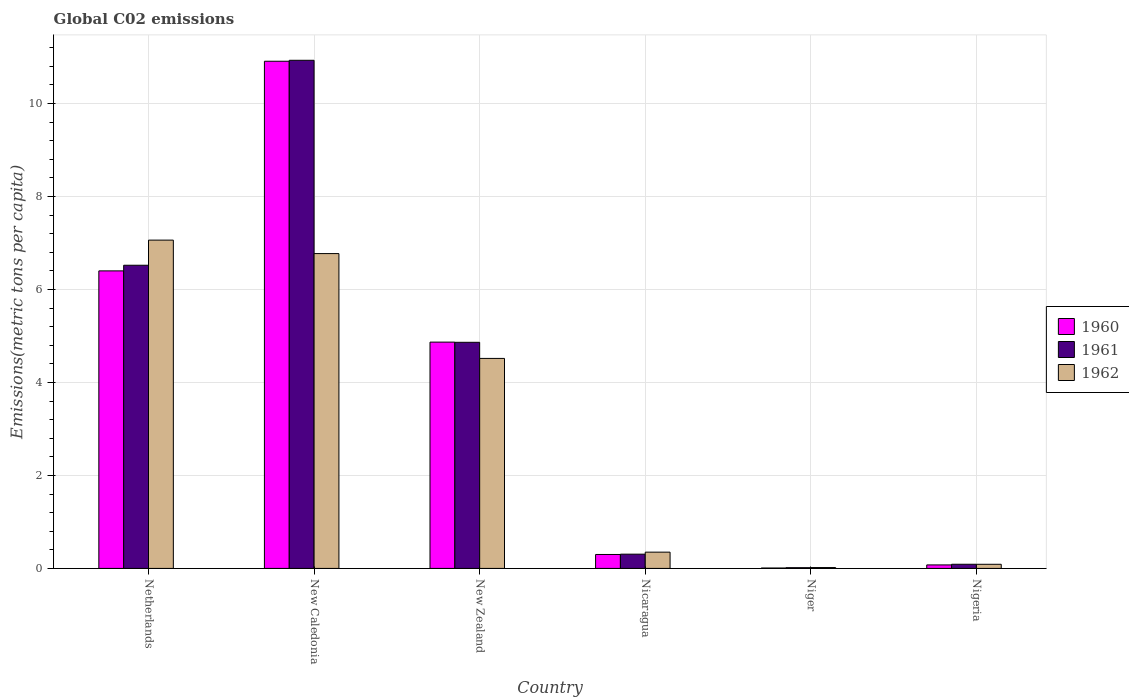How many different coloured bars are there?
Make the answer very short. 3. How many groups of bars are there?
Keep it short and to the point. 6. How many bars are there on the 4th tick from the left?
Make the answer very short. 3. What is the label of the 5th group of bars from the left?
Make the answer very short. Niger. In how many cases, is the number of bars for a given country not equal to the number of legend labels?
Your answer should be very brief. 0. What is the amount of CO2 emitted in in 1960 in New Zealand?
Provide a succinct answer. 4.87. Across all countries, what is the maximum amount of CO2 emitted in in 1962?
Your response must be concise. 7.06. Across all countries, what is the minimum amount of CO2 emitted in in 1961?
Your answer should be compact. 0.02. In which country was the amount of CO2 emitted in in 1961 maximum?
Your answer should be compact. New Caledonia. In which country was the amount of CO2 emitted in in 1962 minimum?
Give a very brief answer. Niger. What is the total amount of CO2 emitted in in 1961 in the graph?
Provide a succinct answer. 22.72. What is the difference between the amount of CO2 emitted in in 1962 in Netherlands and that in Nigeria?
Keep it short and to the point. 6.97. What is the difference between the amount of CO2 emitted in in 1960 in Nicaragua and the amount of CO2 emitted in in 1962 in New Zealand?
Provide a succinct answer. -4.22. What is the average amount of CO2 emitted in in 1960 per country?
Your response must be concise. 3.76. What is the difference between the amount of CO2 emitted in of/in 1962 and amount of CO2 emitted in of/in 1960 in New Caledonia?
Keep it short and to the point. -4.14. In how many countries, is the amount of CO2 emitted in in 1961 greater than 4 metric tons per capita?
Provide a short and direct response. 3. What is the ratio of the amount of CO2 emitted in in 1960 in Nicaragua to that in Niger?
Make the answer very short. 34.68. Is the amount of CO2 emitted in in 1960 in New Caledonia less than that in Nigeria?
Provide a succinct answer. No. What is the difference between the highest and the second highest amount of CO2 emitted in in 1960?
Provide a short and direct response. 6.04. What is the difference between the highest and the lowest amount of CO2 emitted in in 1960?
Offer a very short reply. 10.9. Is the sum of the amount of CO2 emitted in in 1962 in Netherlands and New Caledonia greater than the maximum amount of CO2 emitted in in 1960 across all countries?
Provide a succinct answer. Yes. What does the 3rd bar from the right in Netherlands represents?
Your response must be concise. 1960. How many countries are there in the graph?
Offer a terse response. 6. Are the values on the major ticks of Y-axis written in scientific E-notation?
Offer a very short reply. No. Where does the legend appear in the graph?
Keep it short and to the point. Center right. How many legend labels are there?
Give a very brief answer. 3. How are the legend labels stacked?
Provide a succinct answer. Vertical. What is the title of the graph?
Offer a terse response. Global C02 emissions. Does "1994" appear as one of the legend labels in the graph?
Your answer should be compact. No. What is the label or title of the Y-axis?
Your response must be concise. Emissions(metric tons per capita). What is the Emissions(metric tons per capita) of 1960 in Netherlands?
Keep it short and to the point. 6.4. What is the Emissions(metric tons per capita) in 1961 in Netherlands?
Keep it short and to the point. 6.52. What is the Emissions(metric tons per capita) of 1962 in Netherlands?
Provide a short and direct response. 7.06. What is the Emissions(metric tons per capita) of 1960 in New Caledonia?
Offer a very short reply. 10.91. What is the Emissions(metric tons per capita) of 1961 in New Caledonia?
Make the answer very short. 10.93. What is the Emissions(metric tons per capita) of 1962 in New Caledonia?
Give a very brief answer. 6.77. What is the Emissions(metric tons per capita) in 1960 in New Zealand?
Provide a short and direct response. 4.87. What is the Emissions(metric tons per capita) of 1961 in New Zealand?
Give a very brief answer. 4.86. What is the Emissions(metric tons per capita) in 1962 in New Zealand?
Ensure brevity in your answer.  4.52. What is the Emissions(metric tons per capita) in 1960 in Nicaragua?
Provide a short and direct response. 0.3. What is the Emissions(metric tons per capita) in 1961 in Nicaragua?
Your answer should be compact. 0.31. What is the Emissions(metric tons per capita) of 1962 in Nicaragua?
Your response must be concise. 0.35. What is the Emissions(metric tons per capita) of 1960 in Niger?
Your answer should be compact. 0.01. What is the Emissions(metric tons per capita) in 1961 in Niger?
Give a very brief answer. 0.02. What is the Emissions(metric tons per capita) of 1962 in Niger?
Provide a short and direct response. 0.02. What is the Emissions(metric tons per capita) in 1960 in Nigeria?
Your response must be concise. 0.08. What is the Emissions(metric tons per capita) in 1961 in Nigeria?
Ensure brevity in your answer.  0.09. What is the Emissions(metric tons per capita) of 1962 in Nigeria?
Offer a very short reply. 0.09. Across all countries, what is the maximum Emissions(metric tons per capita) in 1960?
Your answer should be compact. 10.91. Across all countries, what is the maximum Emissions(metric tons per capita) of 1961?
Make the answer very short. 10.93. Across all countries, what is the maximum Emissions(metric tons per capita) of 1962?
Provide a short and direct response. 7.06. Across all countries, what is the minimum Emissions(metric tons per capita) in 1960?
Offer a very short reply. 0.01. Across all countries, what is the minimum Emissions(metric tons per capita) of 1961?
Provide a succinct answer. 0.02. Across all countries, what is the minimum Emissions(metric tons per capita) in 1962?
Your response must be concise. 0.02. What is the total Emissions(metric tons per capita) in 1960 in the graph?
Make the answer very short. 22.56. What is the total Emissions(metric tons per capita) of 1961 in the graph?
Ensure brevity in your answer.  22.72. What is the total Emissions(metric tons per capita) in 1962 in the graph?
Your answer should be compact. 18.81. What is the difference between the Emissions(metric tons per capita) of 1960 in Netherlands and that in New Caledonia?
Your answer should be very brief. -4.51. What is the difference between the Emissions(metric tons per capita) in 1961 in Netherlands and that in New Caledonia?
Provide a short and direct response. -4.41. What is the difference between the Emissions(metric tons per capita) in 1962 in Netherlands and that in New Caledonia?
Make the answer very short. 0.29. What is the difference between the Emissions(metric tons per capita) in 1960 in Netherlands and that in New Zealand?
Offer a very short reply. 1.53. What is the difference between the Emissions(metric tons per capita) in 1961 in Netherlands and that in New Zealand?
Provide a short and direct response. 1.66. What is the difference between the Emissions(metric tons per capita) of 1962 in Netherlands and that in New Zealand?
Provide a succinct answer. 2.54. What is the difference between the Emissions(metric tons per capita) in 1960 in Netherlands and that in Nicaragua?
Make the answer very short. 6.1. What is the difference between the Emissions(metric tons per capita) of 1961 in Netherlands and that in Nicaragua?
Make the answer very short. 6.21. What is the difference between the Emissions(metric tons per capita) of 1962 in Netherlands and that in Nicaragua?
Provide a short and direct response. 6.71. What is the difference between the Emissions(metric tons per capita) of 1960 in Netherlands and that in Niger?
Your response must be concise. 6.39. What is the difference between the Emissions(metric tons per capita) of 1961 in Netherlands and that in Niger?
Provide a succinct answer. 6.5. What is the difference between the Emissions(metric tons per capita) in 1962 in Netherlands and that in Niger?
Give a very brief answer. 7.04. What is the difference between the Emissions(metric tons per capita) of 1960 in Netherlands and that in Nigeria?
Your answer should be compact. 6.32. What is the difference between the Emissions(metric tons per capita) of 1961 in Netherlands and that in Nigeria?
Give a very brief answer. 6.43. What is the difference between the Emissions(metric tons per capita) in 1962 in Netherlands and that in Nigeria?
Your response must be concise. 6.97. What is the difference between the Emissions(metric tons per capita) in 1960 in New Caledonia and that in New Zealand?
Keep it short and to the point. 6.04. What is the difference between the Emissions(metric tons per capita) in 1961 in New Caledonia and that in New Zealand?
Your response must be concise. 6.07. What is the difference between the Emissions(metric tons per capita) in 1962 in New Caledonia and that in New Zealand?
Provide a succinct answer. 2.25. What is the difference between the Emissions(metric tons per capita) of 1960 in New Caledonia and that in Nicaragua?
Your response must be concise. 10.61. What is the difference between the Emissions(metric tons per capita) in 1961 in New Caledonia and that in Nicaragua?
Provide a short and direct response. 10.62. What is the difference between the Emissions(metric tons per capita) of 1962 in New Caledonia and that in Nicaragua?
Your answer should be very brief. 6.42. What is the difference between the Emissions(metric tons per capita) of 1960 in New Caledonia and that in Niger?
Give a very brief answer. 10.9. What is the difference between the Emissions(metric tons per capita) in 1961 in New Caledonia and that in Niger?
Provide a succinct answer. 10.91. What is the difference between the Emissions(metric tons per capita) of 1962 in New Caledonia and that in Niger?
Provide a short and direct response. 6.75. What is the difference between the Emissions(metric tons per capita) of 1960 in New Caledonia and that in Nigeria?
Your answer should be very brief. 10.83. What is the difference between the Emissions(metric tons per capita) of 1961 in New Caledonia and that in Nigeria?
Provide a succinct answer. 10.84. What is the difference between the Emissions(metric tons per capita) of 1962 in New Caledonia and that in Nigeria?
Your response must be concise. 6.68. What is the difference between the Emissions(metric tons per capita) of 1960 in New Zealand and that in Nicaragua?
Ensure brevity in your answer.  4.57. What is the difference between the Emissions(metric tons per capita) in 1961 in New Zealand and that in Nicaragua?
Ensure brevity in your answer.  4.56. What is the difference between the Emissions(metric tons per capita) of 1962 in New Zealand and that in Nicaragua?
Offer a terse response. 4.17. What is the difference between the Emissions(metric tons per capita) in 1960 in New Zealand and that in Niger?
Provide a succinct answer. 4.86. What is the difference between the Emissions(metric tons per capita) of 1961 in New Zealand and that in Niger?
Offer a very short reply. 4.85. What is the difference between the Emissions(metric tons per capita) of 1962 in New Zealand and that in Niger?
Offer a very short reply. 4.5. What is the difference between the Emissions(metric tons per capita) of 1960 in New Zealand and that in Nigeria?
Ensure brevity in your answer.  4.79. What is the difference between the Emissions(metric tons per capita) in 1961 in New Zealand and that in Nigeria?
Your response must be concise. 4.77. What is the difference between the Emissions(metric tons per capita) in 1962 in New Zealand and that in Nigeria?
Offer a terse response. 4.43. What is the difference between the Emissions(metric tons per capita) in 1960 in Nicaragua and that in Niger?
Make the answer very short. 0.29. What is the difference between the Emissions(metric tons per capita) of 1961 in Nicaragua and that in Niger?
Provide a succinct answer. 0.29. What is the difference between the Emissions(metric tons per capita) in 1962 in Nicaragua and that in Niger?
Your answer should be compact. 0.33. What is the difference between the Emissions(metric tons per capita) in 1960 in Nicaragua and that in Nigeria?
Offer a very short reply. 0.22. What is the difference between the Emissions(metric tons per capita) in 1961 in Nicaragua and that in Nigeria?
Your response must be concise. 0.22. What is the difference between the Emissions(metric tons per capita) of 1962 in Nicaragua and that in Nigeria?
Provide a short and direct response. 0.26. What is the difference between the Emissions(metric tons per capita) of 1960 in Niger and that in Nigeria?
Provide a succinct answer. -0.07. What is the difference between the Emissions(metric tons per capita) of 1961 in Niger and that in Nigeria?
Provide a short and direct response. -0.07. What is the difference between the Emissions(metric tons per capita) of 1962 in Niger and that in Nigeria?
Your answer should be very brief. -0.07. What is the difference between the Emissions(metric tons per capita) of 1960 in Netherlands and the Emissions(metric tons per capita) of 1961 in New Caledonia?
Provide a short and direct response. -4.53. What is the difference between the Emissions(metric tons per capita) of 1960 in Netherlands and the Emissions(metric tons per capita) of 1962 in New Caledonia?
Keep it short and to the point. -0.37. What is the difference between the Emissions(metric tons per capita) of 1961 in Netherlands and the Emissions(metric tons per capita) of 1962 in New Caledonia?
Your answer should be compact. -0.25. What is the difference between the Emissions(metric tons per capita) in 1960 in Netherlands and the Emissions(metric tons per capita) in 1961 in New Zealand?
Offer a very short reply. 1.54. What is the difference between the Emissions(metric tons per capita) in 1960 in Netherlands and the Emissions(metric tons per capita) in 1962 in New Zealand?
Provide a short and direct response. 1.88. What is the difference between the Emissions(metric tons per capita) in 1961 in Netherlands and the Emissions(metric tons per capita) in 1962 in New Zealand?
Keep it short and to the point. 2. What is the difference between the Emissions(metric tons per capita) of 1960 in Netherlands and the Emissions(metric tons per capita) of 1961 in Nicaragua?
Your answer should be compact. 6.09. What is the difference between the Emissions(metric tons per capita) in 1960 in Netherlands and the Emissions(metric tons per capita) in 1962 in Nicaragua?
Offer a very short reply. 6.05. What is the difference between the Emissions(metric tons per capita) of 1961 in Netherlands and the Emissions(metric tons per capita) of 1962 in Nicaragua?
Offer a terse response. 6.17. What is the difference between the Emissions(metric tons per capita) in 1960 in Netherlands and the Emissions(metric tons per capita) in 1961 in Niger?
Your response must be concise. 6.38. What is the difference between the Emissions(metric tons per capita) of 1960 in Netherlands and the Emissions(metric tons per capita) of 1962 in Niger?
Provide a succinct answer. 6.38. What is the difference between the Emissions(metric tons per capita) of 1961 in Netherlands and the Emissions(metric tons per capita) of 1962 in Niger?
Make the answer very short. 6.5. What is the difference between the Emissions(metric tons per capita) of 1960 in Netherlands and the Emissions(metric tons per capita) of 1961 in Nigeria?
Your answer should be compact. 6.31. What is the difference between the Emissions(metric tons per capita) of 1960 in Netherlands and the Emissions(metric tons per capita) of 1962 in Nigeria?
Your answer should be very brief. 6.31. What is the difference between the Emissions(metric tons per capita) in 1961 in Netherlands and the Emissions(metric tons per capita) in 1962 in Nigeria?
Give a very brief answer. 6.43. What is the difference between the Emissions(metric tons per capita) in 1960 in New Caledonia and the Emissions(metric tons per capita) in 1961 in New Zealand?
Make the answer very short. 6.04. What is the difference between the Emissions(metric tons per capita) of 1960 in New Caledonia and the Emissions(metric tons per capita) of 1962 in New Zealand?
Your answer should be compact. 6.39. What is the difference between the Emissions(metric tons per capita) in 1961 in New Caledonia and the Emissions(metric tons per capita) in 1962 in New Zealand?
Offer a very short reply. 6.41. What is the difference between the Emissions(metric tons per capita) of 1960 in New Caledonia and the Emissions(metric tons per capita) of 1961 in Nicaragua?
Your answer should be compact. 10.6. What is the difference between the Emissions(metric tons per capita) of 1960 in New Caledonia and the Emissions(metric tons per capita) of 1962 in Nicaragua?
Provide a short and direct response. 10.56. What is the difference between the Emissions(metric tons per capita) of 1961 in New Caledonia and the Emissions(metric tons per capita) of 1962 in Nicaragua?
Provide a succinct answer. 10.58. What is the difference between the Emissions(metric tons per capita) in 1960 in New Caledonia and the Emissions(metric tons per capita) in 1961 in Niger?
Offer a very short reply. 10.89. What is the difference between the Emissions(metric tons per capita) of 1960 in New Caledonia and the Emissions(metric tons per capita) of 1962 in Niger?
Ensure brevity in your answer.  10.89. What is the difference between the Emissions(metric tons per capita) in 1961 in New Caledonia and the Emissions(metric tons per capita) in 1962 in Niger?
Provide a short and direct response. 10.91. What is the difference between the Emissions(metric tons per capita) of 1960 in New Caledonia and the Emissions(metric tons per capita) of 1961 in Nigeria?
Your answer should be very brief. 10.82. What is the difference between the Emissions(metric tons per capita) of 1960 in New Caledonia and the Emissions(metric tons per capita) of 1962 in Nigeria?
Your answer should be compact. 10.82. What is the difference between the Emissions(metric tons per capita) of 1961 in New Caledonia and the Emissions(metric tons per capita) of 1962 in Nigeria?
Provide a short and direct response. 10.84. What is the difference between the Emissions(metric tons per capita) in 1960 in New Zealand and the Emissions(metric tons per capita) in 1961 in Nicaragua?
Offer a terse response. 4.56. What is the difference between the Emissions(metric tons per capita) of 1960 in New Zealand and the Emissions(metric tons per capita) of 1962 in Nicaragua?
Provide a succinct answer. 4.52. What is the difference between the Emissions(metric tons per capita) in 1961 in New Zealand and the Emissions(metric tons per capita) in 1962 in Nicaragua?
Keep it short and to the point. 4.51. What is the difference between the Emissions(metric tons per capita) of 1960 in New Zealand and the Emissions(metric tons per capita) of 1961 in Niger?
Your answer should be compact. 4.85. What is the difference between the Emissions(metric tons per capita) of 1960 in New Zealand and the Emissions(metric tons per capita) of 1962 in Niger?
Give a very brief answer. 4.85. What is the difference between the Emissions(metric tons per capita) in 1961 in New Zealand and the Emissions(metric tons per capita) in 1962 in Niger?
Your answer should be compact. 4.84. What is the difference between the Emissions(metric tons per capita) in 1960 in New Zealand and the Emissions(metric tons per capita) in 1961 in Nigeria?
Keep it short and to the point. 4.78. What is the difference between the Emissions(metric tons per capita) of 1960 in New Zealand and the Emissions(metric tons per capita) of 1962 in Nigeria?
Give a very brief answer. 4.78. What is the difference between the Emissions(metric tons per capita) in 1961 in New Zealand and the Emissions(metric tons per capita) in 1962 in Nigeria?
Give a very brief answer. 4.77. What is the difference between the Emissions(metric tons per capita) in 1960 in Nicaragua and the Emissions(metric tons per capita) in 1961 in Niger?
Keep it short and to the point. 0.28. What is the difference between the Emissions(metric tons per capita) of 1960 in Nicaragua and the Emissions(metric tons per capita) of 1962 in Niger?
Give a very brief answer. 0.28. What is the difference between the Emissions(metric tons per capita) of 1961 in Nicaragua and the Emissions(metric tons per capita) of 1962 in Niger?
Your answer should be compact. 0.29. What is the difference between the Emissions(metric tons per capita) in 1960 in Nicaragua and the Emissions(metric tons per capita) in 1961 in Nigeria?
Make the answer very short. 0.21. What is the difference between the Emissions(metric tons per capita) in 1960 in Nicaragua and the Emissions(metric tons per capita) in 1962 in Nigeria?
Your answer should be very brief. 0.21. What is the difference between the Emissions(metric tons per capita) in 1961 in Nicaragua and the Emissions(metric tons per capita) in 1962 in Nigeria?
Offer a terse response. 0.22. What is the difference between the Emissions(metric tons per capita) of 1960 in Niger and the Emissions(metric tons per capita) of 1961 in Nigeria?
Make the answer very short. -0.08. What is the difference between the Emissions(metric tons per capita) in 1960 in Niger and the Emissions(metric tons per capita) in 1962 in Nigeria?
Ensure brevity in your answer.  -0.08. What is the difference between the Emissions(metric tons per capita) of 1961 in Niger and the Emissions(metric tons per capita) of 1962 in Nigeria?
Your response must be concise. -0.07. What is the average Emissions(metric tons per capita) of 1960 per country?
Your answer should be compact. 3.76. What is the average Emissions(metric tons per capita) of 1961 per country?
Provide a succinct answer. 3.79. What is the average Emissions(metric tons per capita) of 1962 per country?
Ensure brevity in your answer.  3.13. What is the difference between the Emissions(metric tons per capita) in 1960 and Emissions(metric tons per capita) in 1961 in Netherlands?
Your answer should be compact. -0.12. What is the difference between the Emissions(metric tons per capita) in 1960 and Emissions(metric tons per capita) in 1962 in Netherlands?
Your answer should be very brief. -0.66. What is the difference between the Emissions(metric tons per capita) in 1961 and Emissions(metric tons per capita) in 1962 in Netherlands?
Offer a very short reply. -0.54. What is the difference between the Emissions(metric tons per capita) in 1960 and Emissions(metric tons per capita) in 1961 in New Caledonia?
Your answer should be compact. -0.02. What is the difference between the Emissions(metric tons per capita) of 1960 and Emissions(metric tons per capita) of 1962 in New Caledonia?
Your answer should be very brief. 4.14. What is the difference between the Emissions(metric tons per capita) in 1961 and Emissions(metric tons per capita) in 1962 in New Caledonia?
Your answer should be compact. 4.16. What is the difference between the Emissions(metric tons per capita) of 1960 and Emissions(metric tons per capita) of 1961 in New Zealand?
Provide a succinct answer. 0. What is the difference between the Emissions(metric tons per capita) in 1960 and Emissions(metric tons per capita) in 1962 in New Zealand?
Ensure brevity in your answer.  0.35. What is the difference between the Emissions(metric tons per capita) of 1961 and Emissions(metric tons per capita) of 1962 in New Zealand?
Your answer should be very brief. 0.35. What is the difference between the Emissions(metric tons per capita) in 1960 and Emissions(metric tons per capita) in 1961 in Nicaragua?
Provide a short and direct response. -0.01. What is the difference between the Emissions(metric tons per capita) in 1960 and Emissions(metric tons per capita) in 1962 in Nicaragua?
Give a very brief answer. -0.05. What is the difference between the Emissions(metric tons per capita) in 1961 and Emissions(metric tons per capita) in 1962 in Nicaragua?
Give a very brief answer. -0.04. What is the difference between the Emissions(metric tons per capita) in 1960 and Emissions(metric tons per capita) in 1961 in Niger?
Your response must be concise. -0.01. What is the difference between the Emissions(metric tons per capita) in 1960 and Emissions(metric tons per capita) in 1962 in Niger?
Your answer should be compact. -0.01. What is the difference between the Emissions(metric tons per capita) in 1961 and Emissions(metric tons per capita) in 1962 in Niger?
Your answer should be compact. -0. What is the difference between the Emissions(metric tons per capita) in 1960 and Emissions(metric tons per capita) in 1961 in Nigeria?
Provide a short and direct response. -0.01. What is the difference between the Emissions(metric tons per capita) in 1960 and Emissions(metric tons per capita) in 1962 in Nigeria?
Offer a very short reply. -0.01. What is the ratio of the Emissions(metric tons per capita) of 1960 in Netherlands to that in New Caledonia?
Provide a succinct answer. 0.59. What is the ratio of the Emissions(metric tons per capita) in 1961 in Netherlands to that in New Caledonia?
Give a very brief answer. 0.6. What is the ratio of the Emissions(metric tons per capita) in 1962 in Netherlands to that in New Caledonia?
Offer a terse response. 1.04. What is the ratio of the Emissions(metric tons per capita) of 1960 in Netherlands to that in New Zealand?
Provide a succinct answer. 1.31. What is the ratio of the Emissions(metric tons per capita) in 1961 in Netherlands to that in New Zealand?
Make the answer very short. 1.34. What is the ratio of the Emissions(metric tons per capita) of 1962 in Netherlands to that in New Zealand?
Provide a succinct answer. 1.56. What is the ratio of the Emissions(metric tons per capita) in 1960 in Netherlands to that in Nicaragua?
Offer a terse response. 21.36. What is the ratio of the Emissions(metric tons per capita) in 1961 in Netherlands to that in Nicaragua?
Give a very brief answer. 21.27. What is the ratio of the Emissions(metric tons per capita) of 1962 in Netherlands to that in Nicaragua?
Provide a succinct answer. 20.18. What is the ratio of the Emissions(metric tons per capita) of 1960 in Netherlands to that in Niger?
Keep it short and to the point. 740.61. What is the ratio of the Emissions(metric tons per capita) of 1961 in Netherlands to that in Niger?
Ensure brevity in your answer.  414.14. What is the ratio of the Emissions(metric tons per capita) in 1962 in Netherlands to that in Niger?
Your response must be concise. 384.74. What is the ratio of the Emissions(metric tons per capita) in 1960 in Netherlands to that in Nigeria?
Give a very brief answer. 84.93. What is the ratio of the Emissions(metric tons per capita) in 1961 in Netherlands to that in Nigeria?
Make the answer very short. 73.13. What is the ratio of the Emissions(metric tons per capita) in 1962 in Netherlands to that in Nigeria?
Provide a short and direct response. 79.58. What is the ratio of the Emissions(metric tons per capita) in 1960 in New Caledonia to that in New Zealand?
Make the answer very short. 2.24. What is the ratio of the Emissions(metric tons per capita) in 1961 in New Caledonia to that in New Zealand?
Give a very brief answer. 2.25. What is the ratio of the Emissions(metric tons per capita) in 1962 in New Caledonia to that in New Zealand?
Provide a succinct answer. 1.5. What is the ratio of the Emissions(metric tons per capita) of 1960 in New Caledonia to that in Nicaragua?
Your response must be concise. 36.41. What is the ratio of the Emissions(metric tons per capita) in 1961 in New Caledonia to that in Nicaragua?
Ensure brevity in your answer.  35.65. What is the ratio of the Emissions(metric tons per capita) in 1962 in New Caledonia to that in Nicaragua?
Keep it short and to the point. 19.35. What is the ratio of the Emissions(metric tons per capita) in 1960 in New Caledonia to that in Niger?
Give a very brief answer. 1262.46. What is the ratio of the Emissions(metric tons per capita) in 1961 in New Caledonia to that in Niger?
Ensure brevity in your answer.  694.14. What is the ratio of the Emissions(metric tons per capita) in 1962 in New Caledonia to that in Niger?
Provide a short and direct response. 368.96. What is the ratio of the Emissions(metric tons per capita) in 1960 in New Caledonia to that in Nigeria?
Provide a short and direct response. 144.77. What is the ratio of the Emissions(metric tons per capita) in 1961 in New Caledonia to that in Nigeria?
Keep it short and to the point. 122.57. What is the ratio of the Emissions(metric tons per capita) in 1962 in New Caledonia to that in Nigeria?
Your response must be concise. 76.32. What is the ratio of the Emissions(metric tons per capita) of 1960 in New Zealand to that in Nicaragua?
Give a very brief answer. 16.24. What is the ratio of the Emissions(metric tons per capita) in 1961 in New Zealand to that in Nicaragua?
Ensure brevity in your answer.  15.87. What is the ratio of the Emissions(metric tons per capita) of 1962 in New Zealand to that in Nicaragua?
Ensure brevity in your answer.  12.91. What is the ratio of the Emissions(metric tons per capita) in 1960 in New Zealand to that in Niger?
Offer a terse response. 563.29. What is the ratio of the Emissions(metric tons per capita) of 1961 in New Zealand to that in Niger?
Ensure brevity in your answer.  308.88. What is the ratio of the Emissions(metric tons per capita) of 1962 in New Zealand to that in Niger?
Offer a very short reply. 246.1. What is the ratio of the Emissions(metric tons per capita) in 1960 in New Zealand to that in Nigeria?
Give a very brief answer. 64.59. What is the ratio of the Emissions(metric tons per capita) of 1961 in New Zealand to that in Nigeria?
Offer a very short reply. 54.54. What is the ratio of the Emissions(metric tons per capita) of 1962 in New Zealand to that in Nigeria?
Provide a short and direct response. 50.91. What is the ratio of the Emissions(metric tons per capita) in 1960 in Nicaragua to that in Niger?
Offer a terse response. 34.68. What is the ratio of the Emissions(metric tons per capita) of 1961 in Nicaragua to that in Niger?
Your answer should be very brief. 19.47. What is the ratio of the Emissions(metric tons per capita) in 1962 in Nicaragua to that in Niger?
Your response must be concise. 19.06. What is the ratio of the Emissions(metric tons per capita) of 1960 in Nicaragua to that in Nigeria?
Provide a short and direct response. 3.98. What is the ratio of the Emissions(metric tons per capita) in 1961 in Nicaragua to that in Nigeria?
Your answer should be compact. 3.44. What is the ratio of the Emissions(metric tons per capita) of 1962 in Nicaragua to that in Nigeria?
Your answer should be very brief. 3.94. What is the ratio of the Emissions(metric tons per capita) of 1960 in Niger to that in Nigeria?
Offer a very short reply. 0.11. What is the ratio of the Emissions(metric tons per capita) in 1961 in Niger to that in Nigeria?
Offer a very short reply. 0.18. What is the ratio of the Emissions(metric tons per capita) in 1962 in Niger to that in Nigeria?
Make the answer very short. 0.21. What is the difference between the highest and the second highest Emissions(metric tons per capita) of 1960?
Offer a very short reply. 4.51. What is the difference between the highest and the second highest Emissions(metric tons per capita) of 1961?
Offer a terse response. 4.41. What is the difference between the highest and the second highest Emissions(metric tons per capita) of 1962?
Your answer should be very brief. 0.29. What is the difference between the highest and the lowest Emissions(metric tons per capita) in 1960?
Your answer should be compact. 10.9. What is the difference between the highest and the lowest Emissions(metric tons per capita) in 1961?
Your answer should be very brief. 10.91. What is the difference between the highest and the lowest Emissions(metric tons per capita) of 1962?
Offer a terse response. 7.04. 